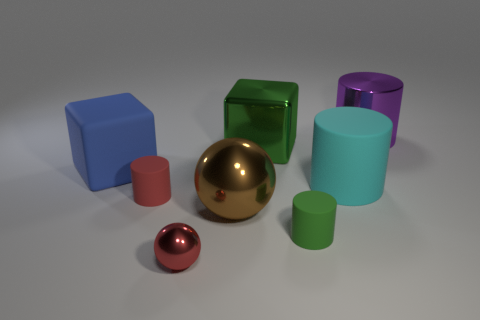Subtract all big purple metal cylinders. How many cylinders are left? 3 Add 1 tiny gray cylinders. How many objects exist? 9 Subtract all balls. How many objects are left? 6 Subtract 2 cylinders. How many cylinders are left? 2 Add 6 large brown metal objects. How many large brown metal objects are left? 7 Add 7 small rubber spheres. How many small rubber spheres exist? 7 Subtract all blue blocks. How many blocks are left? 1 Subtract 1 blue blocks. How many objects are left? 7 Subtract all green cylinders. Subtract all purple blocks. How many cylinders are left? 3 Subtract all big blue blocks. Subtract all big blue rubber things. How many objects are left? 6 